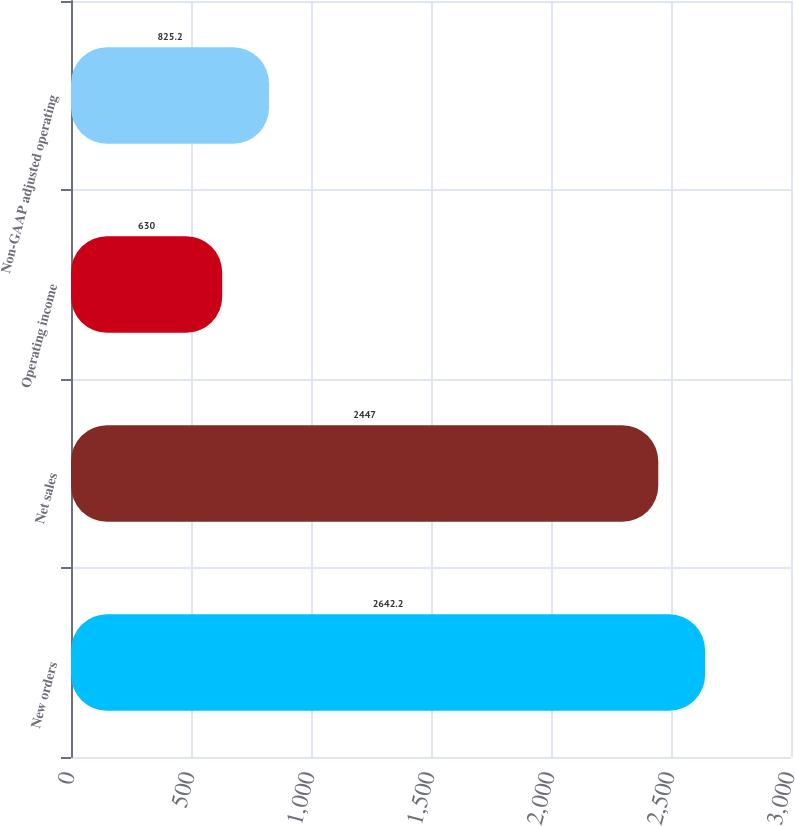<chart> <loc_0><loc_0><loc_500><loc_500><bar_chart><fcel>New orders<fcel>Net sales<fcel>Operating income<fcel>Non-GAAP adjusted operating<nl><fcel>2642.2<fcel>2447<fcel>630<fcel>825.2<nl></chart> 